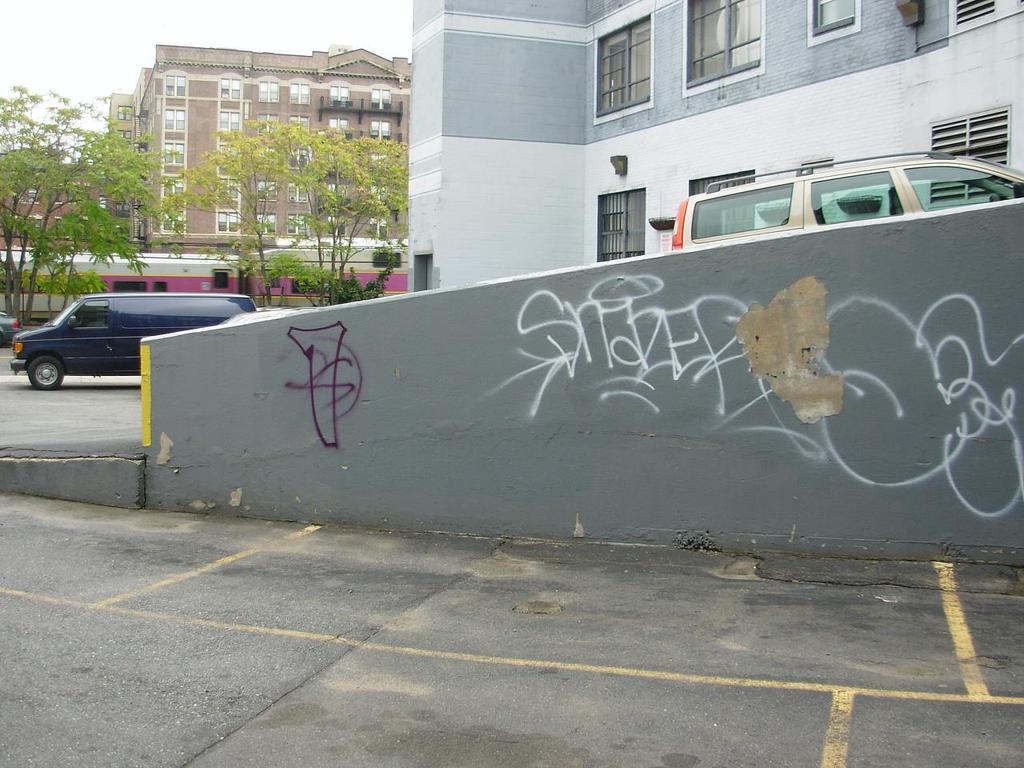Can you describe this image briefly? In the picture I can see trees, buildings, vehicles on the road, a wall which has something written on it and some other objects on the ground. In the background I can see the sky. 